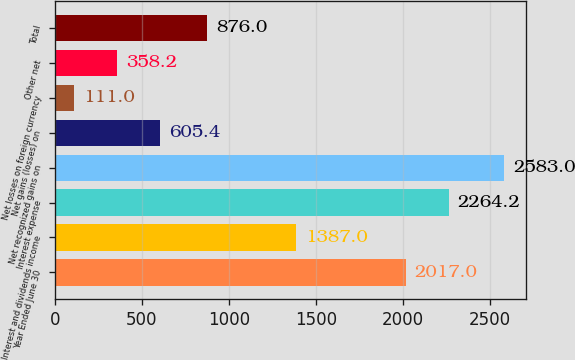Convert chart to OTSL. <chart><loc_0><loc_0><loc_500><loc_500><bar_chart><fcel>Year Ended June 30<fcel>Interest and dividends income<fcel>Interest expense<fcel>Net recognized gains on<fcel>Net gains (losses) on<fcel>Net losses on foreign currency<fcel>Other net<fcel>Total<nl><fcel>2017<fcel>1387<fcel>2264.2<fcel>2583<fcel>605.4<fcel>111<fcel>358.2<fcel>876<nl></chart> 